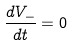Convert formula to latex. <formula><loc_0><loc_0><loc_500><loc_500>\frac { d V _ { - } } { d t } = 0</formula> 